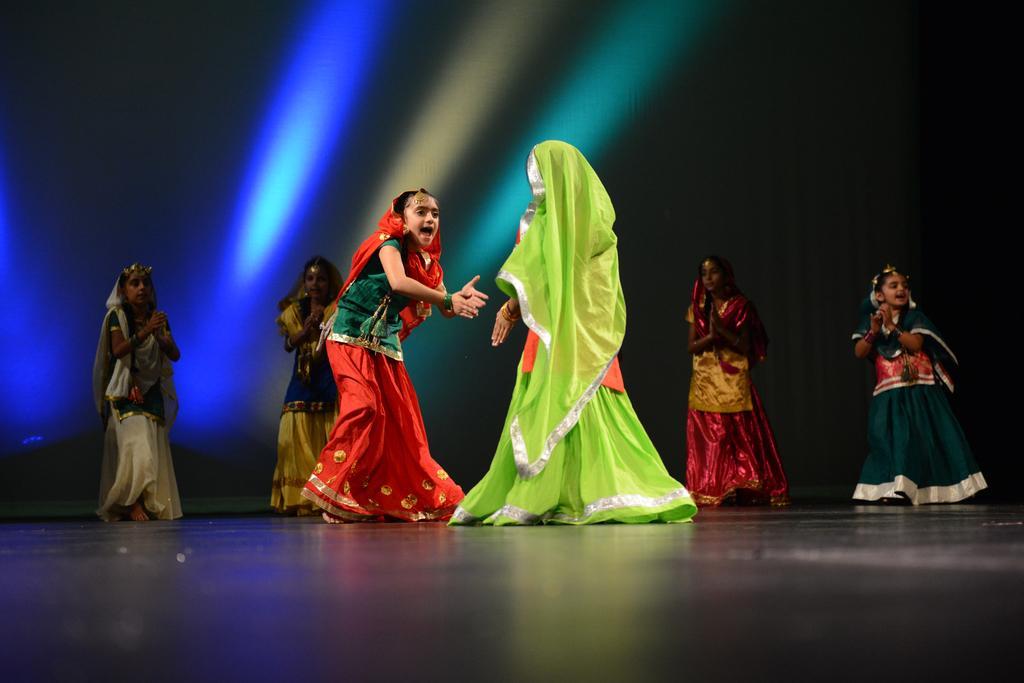Please provide a concise description of this image. In this image we can see group of kids wearing traditional dress dancing on stage and in the background of the image there is black color sheet and we can see some lights are falling. 